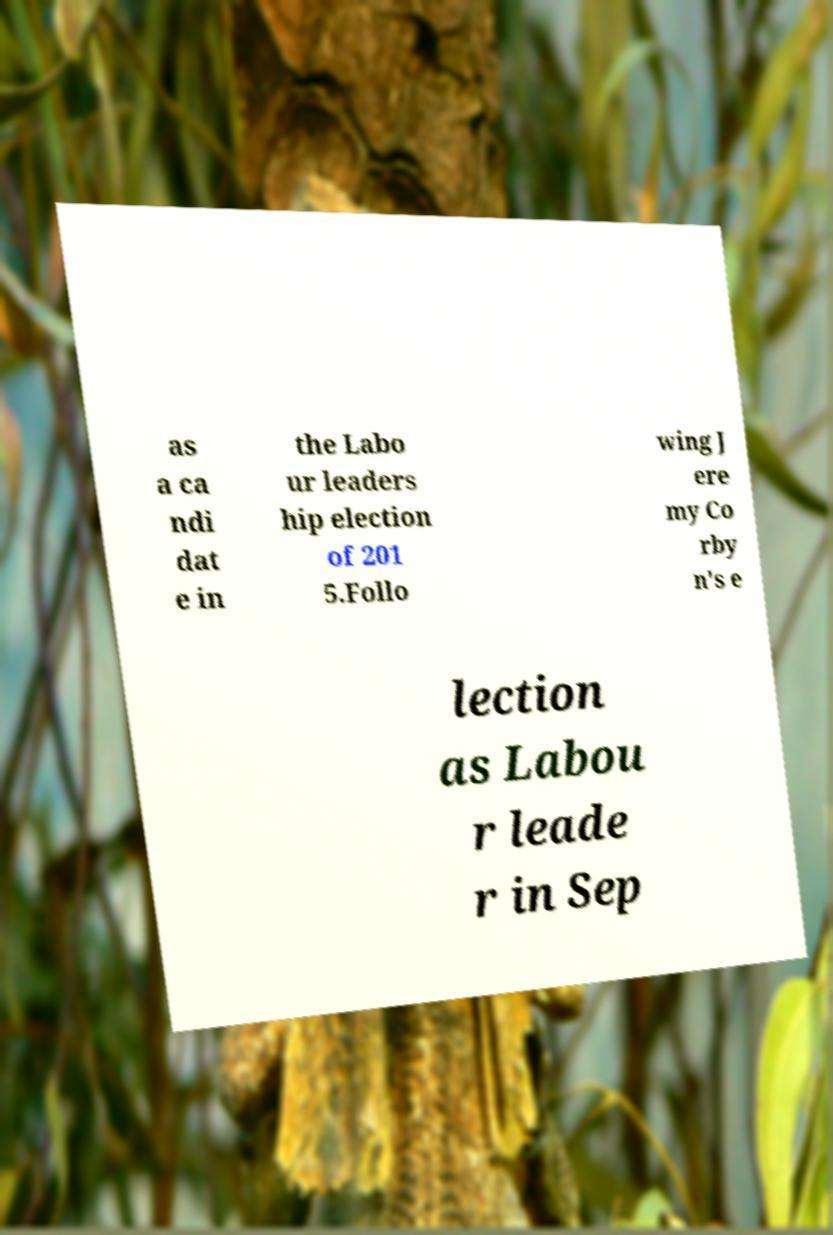Please identify and transcribe the text found in this image. as a ca ndi dat e in the Labo ur leaders hip election of 201 5.Follo wing J ere my Co rby n's e lection as Labou r leade r in Sep 